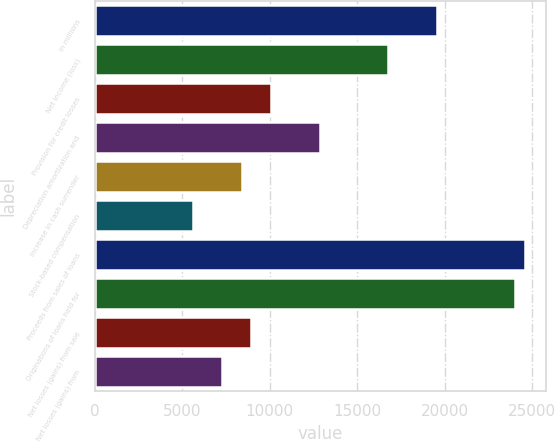Convert chart. <chart><loc_0><loc_0><loc_500><loc_500><bar_chart><fcel>in millions<fcel>Net income (loss)<fcel>Provision for credit losses<fcel>Depreciation amortization and<fcel>Increase in cash surrender<fcel>Stock-based compensation<fcel>Proceeds from sales of loans<fcel>Originations of loans held for<fcel>Net losses (gains) from sale<fcel>Net losses (gains) from<nl><fcel>19567.5<fcel>16773<fcel>10066.2<fcel>12860.7<fcel>8389.5<fcel>5595<fcel>24597.6<fcel>24038.7<fcel>8948.4<fcel>7271.7<nl></chart> 